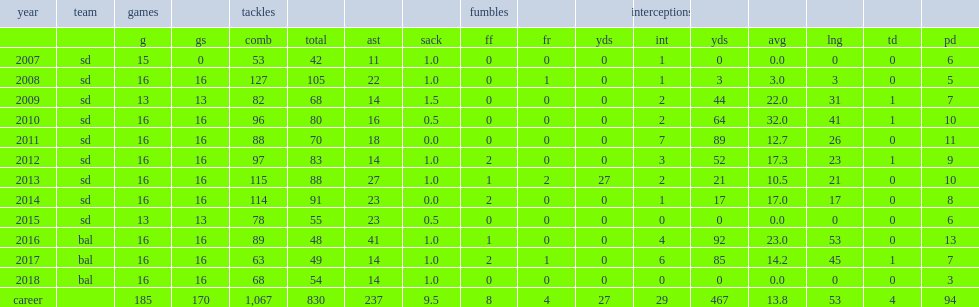How many combined tackles did weddle get in 2013? 88.0. 